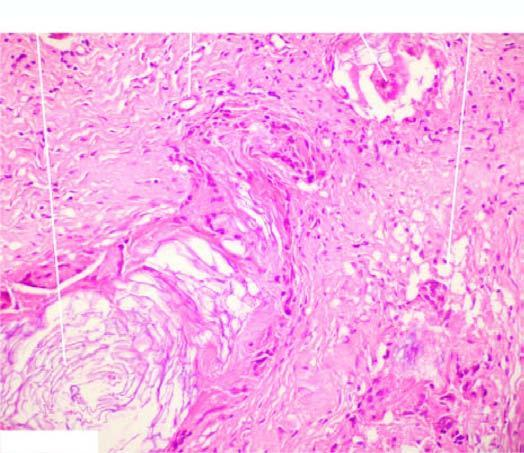s the free left ventricular wall chronic inflammatory granulation tissue and foreign body giant cells around the cholesterol clefts and some pink keratinous material?
Answer the question using a single word or phrase. No 